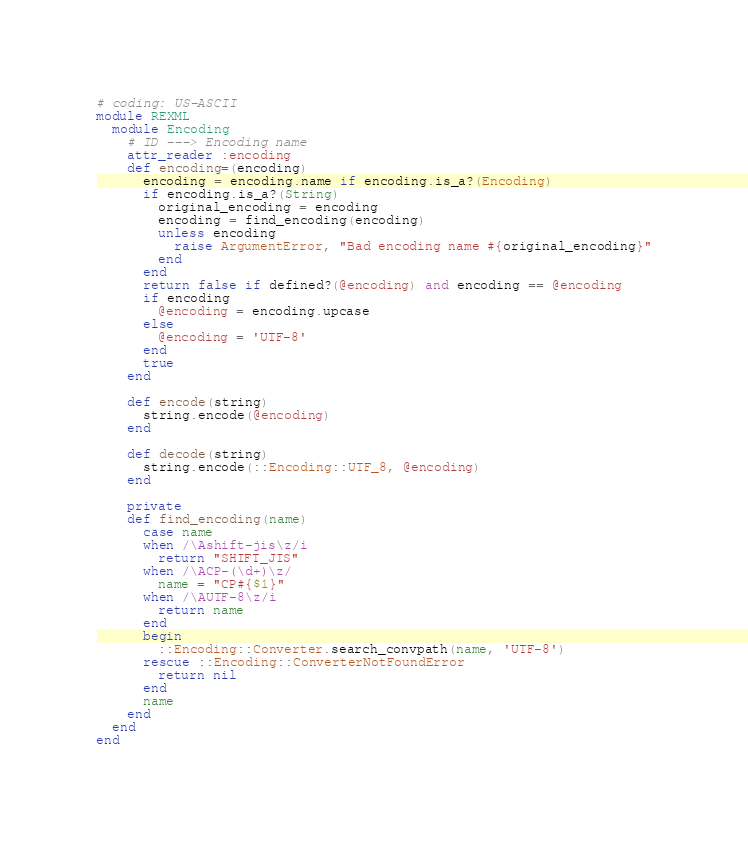Convert code to text. <code><loc_0><loc_0><loc_500><loc_500><_Ruby_># coding: US-ASCII
module REXML
  module Encoding
    # ID ---> Encoding name
    attr_reader :encoding
    def encoding=(encoding)
      encoding = encoding.name if encoding.is_a?(Encoding)
      if encoding.is_a?(String)
        original_encoding = encoding
        encoding = find_encoding(encoding)
        unless encoding
          raise ArgumentError, "Bad encoding name #{original_encoding}"
        end
      end
      return false if defined?(@encoding) and encoding == @encoding
      if encoding
        @encoding = encoding.upcase
      else
        @encoding = 'UTF-8'
      end
      true
    end

    def encode(string)
      string.encode(@encoding)
    end

    def decode(string)
      string.encode(::Encoding::UTF_8, @encoding)
    end

    private
    def find_encoding(name)
      case name
      when /\Ashift-jis\z/i
        return "SHIFT_JIS"
      when /\ACP-(\d+)\z/
        name = "CP#{$1}"
      when /\AUTF-8\z/i
        return name
      end
      begin
        ::Encoding::Converter.search_convpath(name, 'UTF-8')
      rescue ::Encoding::ConverterNotFoundError
        return nil
      end
      name
    end
  end
end
</code> 